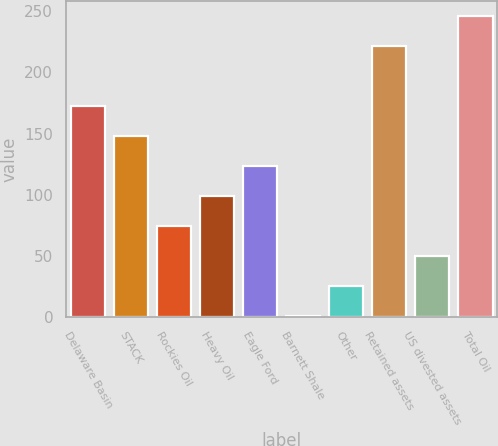<chart> <loc_0><loc_0><loc_500><loc_500><bar_chart><fcel>Delaware Basin<fcel>STACK<fcel>Rockies Oil<fcel>Heavy Oil<fcel>Eagle Ford<fcel>Barnett Shale<fcel>Other<fcel>Retained assets<fcel>US divested assets<fcel>Total Oil<nl><fcel>172.5<fcel>148<fcel>74.5<fcel>99<fcel>123.5<fcel>1<fcel>25.5<fcel>221.5<fcel>50<fcel>246<nl></chart> 